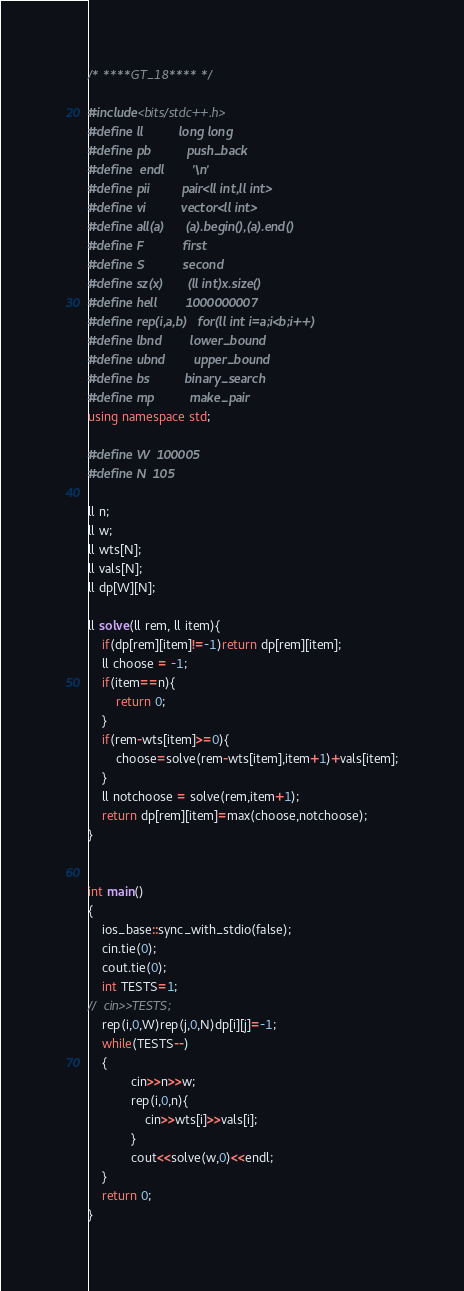<code> <loc_0><loc_0><loc_500><loc_500><_C++_>/* ****GT_18**** */

#include<bits/stdc++.h>
#define ll          long long
#define pb          push_back
#define	endl		'\n'
#define pii         pair<ll int,ll int>
#define vi          vector<ll int>
#define all(a)      (a).begin(),(a).end()
#define F           first
#define S           second
#define sz(x)       (ll int)x.size()
#define hell        1000000007
#define rep(i,a,b)	for(ll int i=a;i<b;i++)
#define lbnd        lower_bound
#define ubnd        upper_bound
#define bs          binary_search
#define mp          make_pair
using namespace std;

#define W  100005
#define N  105

ll n;
ll w;
ll wts[N];
ll vals[N];
ll dp[W][N];

ll solve(ll rem, ll item){
	if(dp[rem][item]!=-1)return dp[rem][item];
	ll choose = -1;
	if(item==n){
		return 0;
	}
	if(rem-wts[item]>=0){
		choose=solve(rem-wts[item],item+1)+vals[item];
	}
	ll notchoose = solve(rem,item+1);
	return dp[rem][item]=max(choose,notchoose);
}


int main()
{
	ios_base::sync_with_stdio(false);
	cin.tie(0);
	cout.tie(0);
	int TESTS=1;
//	cin>>TESTS;
	rep(i,0,W)rep(j,0,N)dp[i][j]=-1;
	while(TESTS--)
	{
			cin>>n>>w;
			rep(i,0,n){
				cin>>wts[i]>>vals[i];
			}
			cout<<solve(w,0)<<endl;
	}
	return 0;
}</code> 